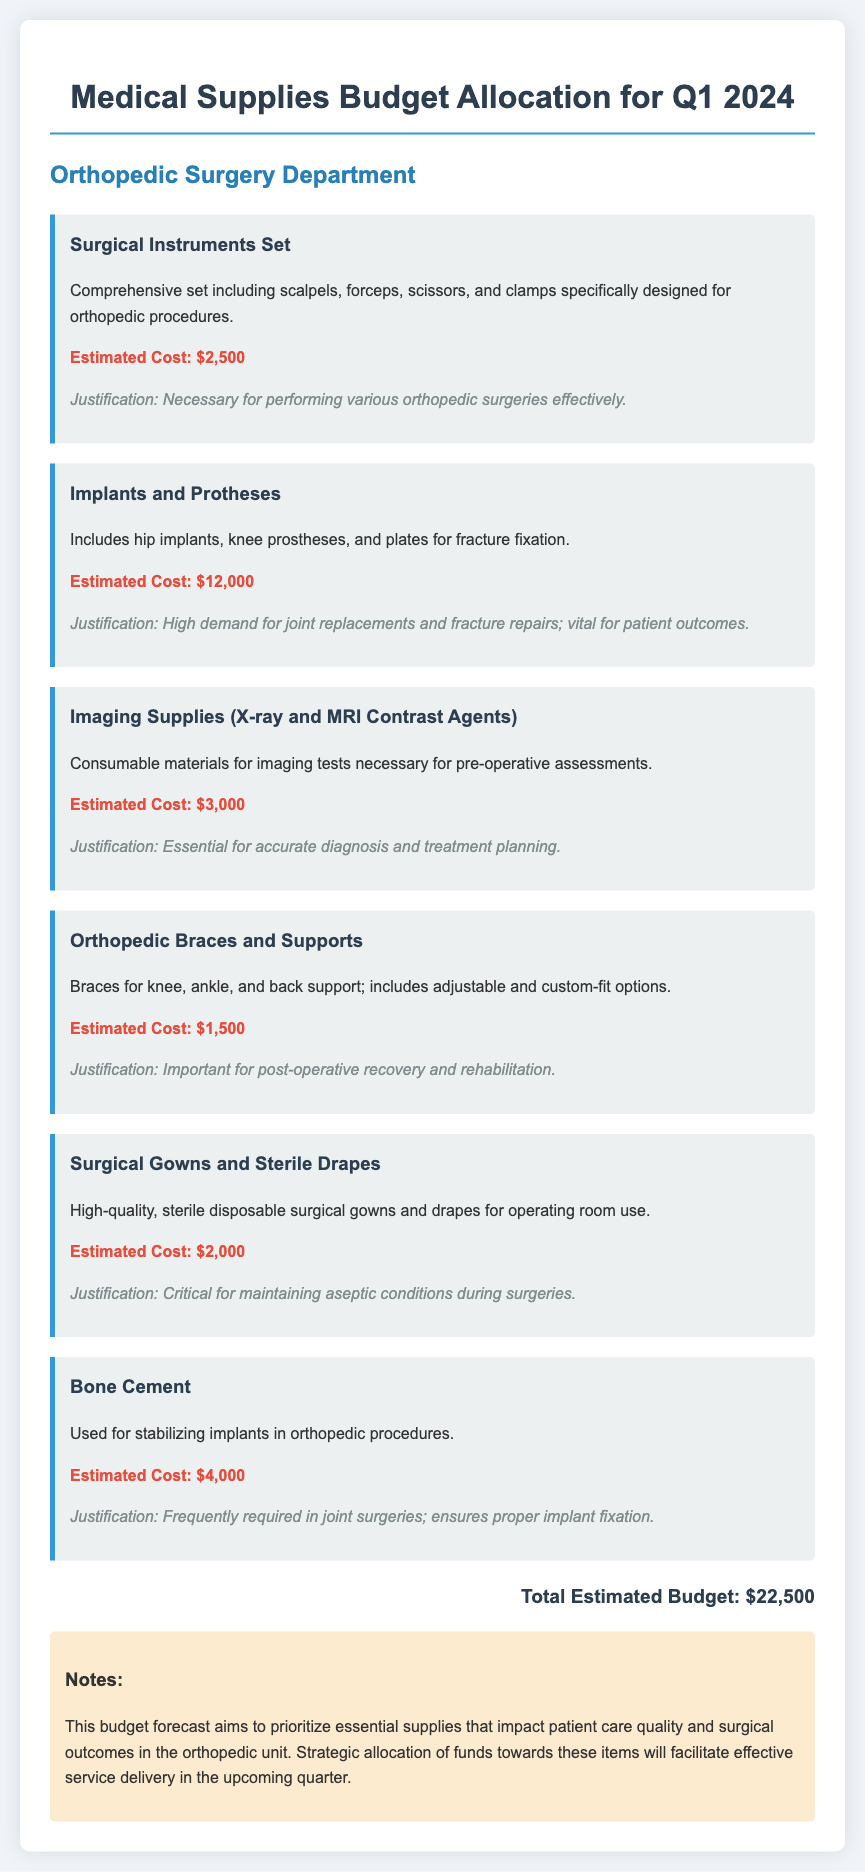What is the total estimated budget? The total estimated budget is the sum of all items listed in the budget allocation, which is $22,500.
Answer: $22,500 What is the estimated cost of implants and prostheses? This cost represents the financial allocation for hip implants, knee prostheses, and plates for fracture fixation outlined in the document.
Answer: $12,000 Which item is deemed necessary for maintaining aseptic conditions during surgeries? This question targets the specific supplies that help prevent infection within the operating room environment.
Answer: Surgical Gowns and Sterile Drapes What is included in the surgical instruments set? This item details the specific types of instruments that are encompassed in the surgical set and their application in the orthopedic field.
Answer: scalpels, forceps, scissors, and clamps How much is allocated for orthopedic braces and supports? This allocation indicates the budget for various orthopedic braces mentioned in the document.
Answer: $1,500 What is the justification for purchasing bone cement? The reasoning provided specifies the requirement for this item in joint surgeries to ensure proper fixation of implants.
Answer: Frequently required in joint surgeries; ensures proper implant fixation What is the main focus of the budget allocation? This question inquires about the overarching goal or intention behind the budget allocation for medical supplies in the orthopedic unit.
Answer: Essential supplies that impact patient care quality and surgical outcomes How many items are listed in the budget allocation? This inquiry aims to find the total count of individual supply items mentioned in the document, capturing detailed aspects of the list.
Answer: Six items 